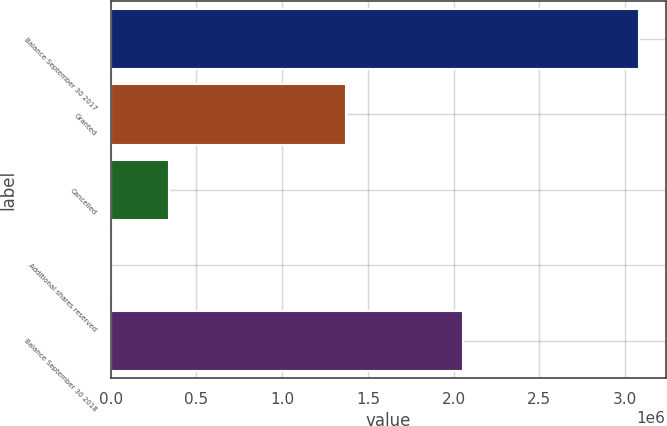<chart> <loc_0><loc_0><loc_500><loc_500><bar_chart><fcel>Balance September 30 2017<fcel>Granted<fcel>Cancelled<fcel>Additional shares reserved<fcel>Balance September 30 2018<nl><fcel>3.08128e+06<fcel>1.36998e+06<fcel>341000<fcel>613<fcel>2.05169e+06<nl></chart> 